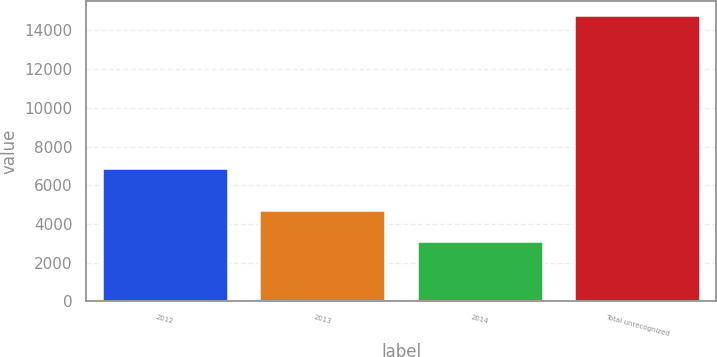Convert chart. <chart><loc_0><loc_0><loc_500><loc_500><bar_chart><fcel>2012<fcel>2013<fcel>2014<fcel>Total unrecognized<nl><fcel>6883<fcel>4722<fcel>3116<fcel>14799<nl></chart> 